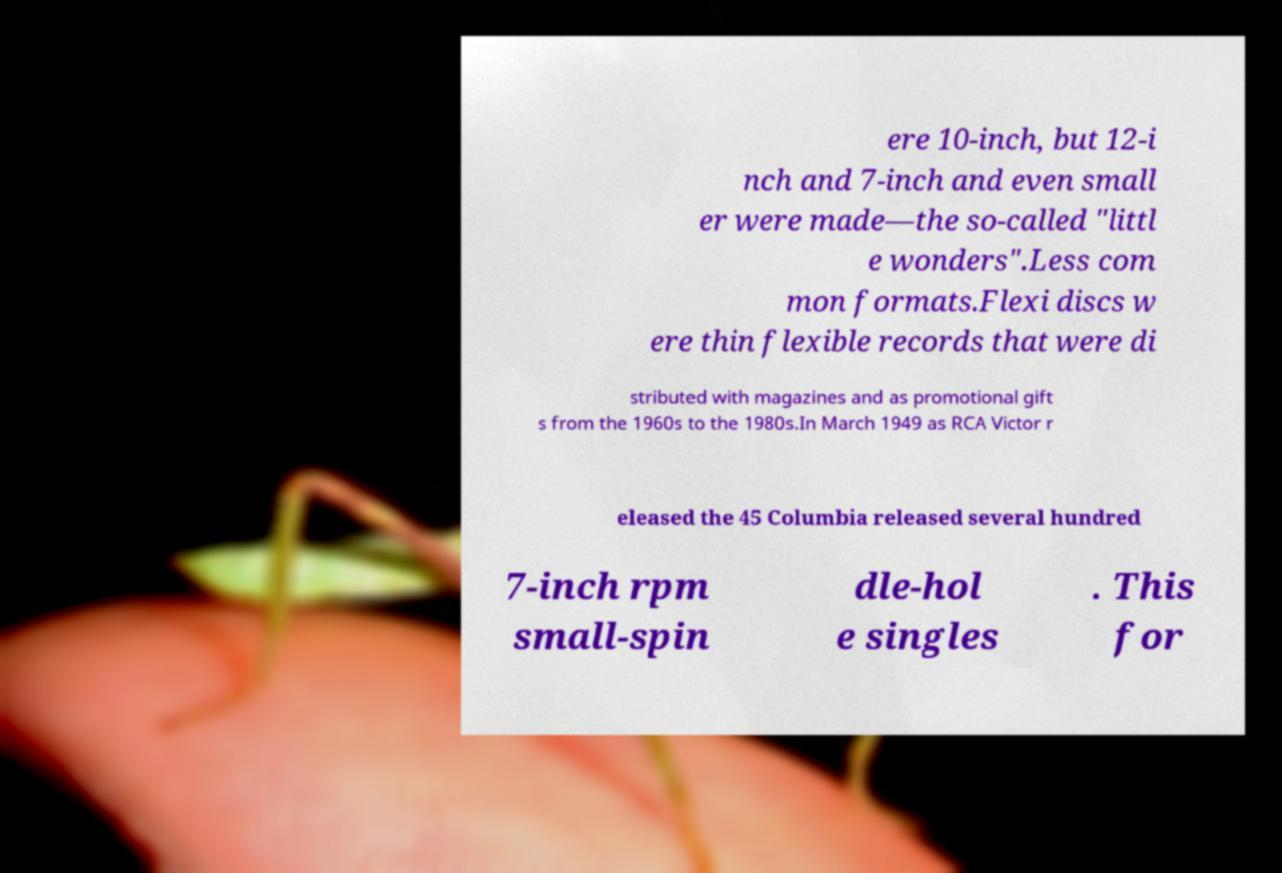I need the written content from this picture converted into text. Can you do that? ere 10-inch, but 12-i nch and 7-inch and even small er were made—the so-called "littl e wonders".Less com mon formats.Flexi discs w ere thin flexible records that were di stributed with magazines and as promotional gift s from the 1960s to the 1980s.In March 1949 as RCA Victor r eleased the 45 Columbia released several hundred 7-inch rpm small-spin dle-hol e singles . This for 